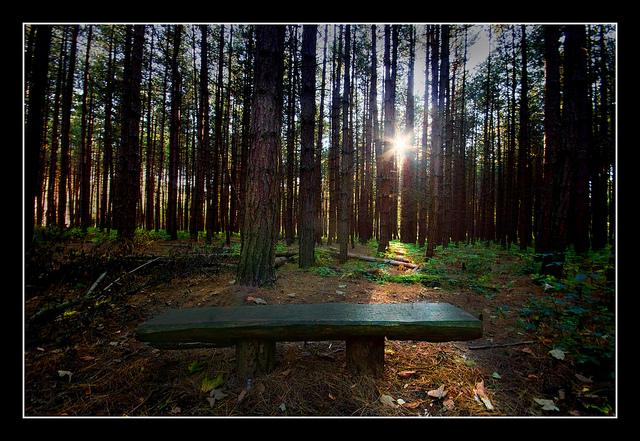Is the sun visible?
Give a very brief answer. Yes. Is the bench occupied?
Give a very brief answer. No. What is the bench made out of?
Concise answer only. Wood. How many places are there to sit down?
Keep it brief. 1. Are there pine needles on the ground?
Concise answer only. Yes. Is this a forest?
Be succinct. Yes. What is this object?
Be succinct. Bench. How many fire hydrants are there?
Be succinct. 0. What color are the plants?
Keep it brief. Green. 